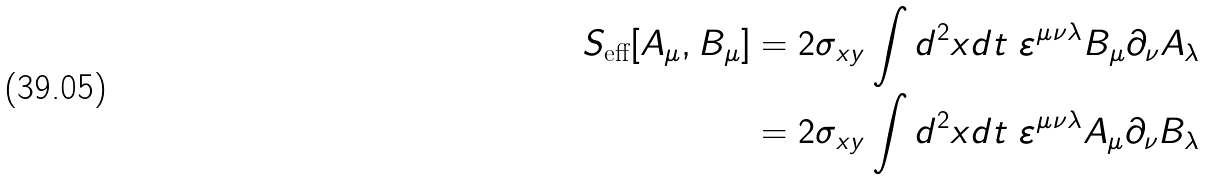Convert formula to latex. <formula><loc_0><loc_0><loc_500><loc_500>S _ { \text {eff} } [ A _ { \mu } , B _ { \mu } ] & = 2 \sigma _ { x y } \int d ^ { 2 } x d t \ \varepsilon ^ { \mu \nu \lambda } B _ { \mu } \partial _ { \nu } A _ { \lambda } \\ & = 2 \sigma _ { x y } \int d ^ { 2 } x d t \ \varepsilon ^ { \mu \nu \lambda } A _ { \mu } \partial _ { \nu } B _ { \lambda }</formula> 